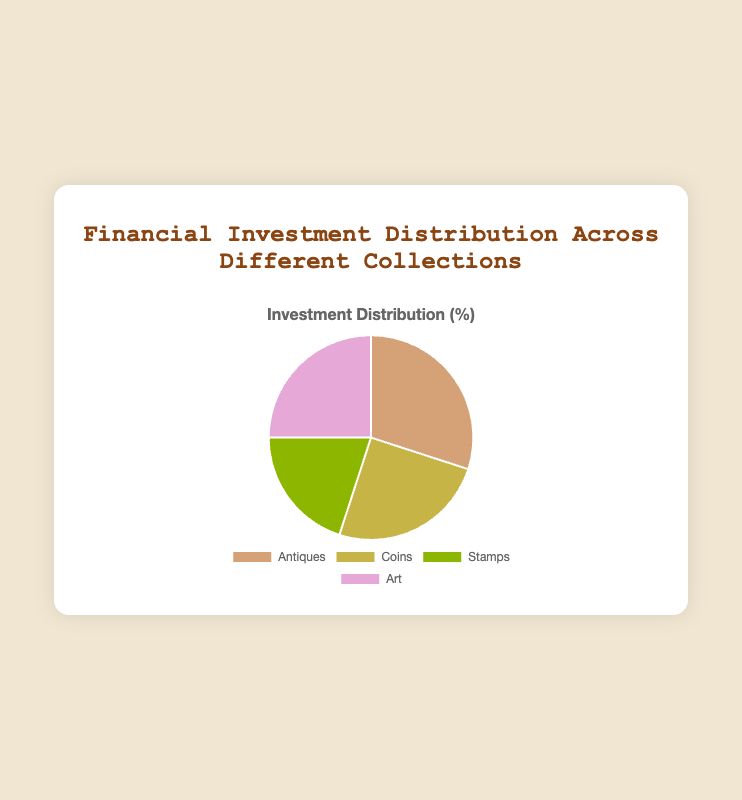What is the total percentage of investment allocated to Coins and Art? To find the total percentage of investment for Coins and Art, you need to sum their individual percentages: 25% (Coins) + 25% (Art) = 50%.
Answer: 50% Which collection has the highest investment percentage? To determine the collection with the highest investment, compare the percentages given: Antiques (30%), Coins (25%), Stamps (20%), and Art (25%). Antiques have the highest percentage at 30%.
Answer: Antiques How many collections have an investment percentage greater than 20%? Identify the collections with investment percentages above 20%. Antiques (30%), Coins (25%), and Art (25%) all exceed 20%. There are 3 collections.
Answer: 3 What is the combined investment percentage for collections with less than 25% investment? Identify the collections with less than 25% investment: Stamps (20%). The percentage is already given as 20%.
Answer: 20% What is the difference in investment percentage between Antiques and Stamps? Subtract the investment percentage of Stamps from that of Antiques: 30% (Antiques) - 20% (Stamps) = 10%.
Answer: 10% Which collection has the lowest investment percentage, and what is it? Compare the percentages provided: Antiques (30%), Coins (25%), Stamps (20%), and Art (25%). Stamps have the lowest investment percentage at 20%.
Answer: Stamps, 20% Is the investment percentage for Antiques more than double compared to Stamps? Double the investment percentage of Stamps (20%) is 40%. The investment percentage for Antiques is 30%, which is less than 40%.
Answer: No What is the average investment percentage across all collections? Sum all the investment percentages and divide by the number of collections: (30% + 25% + 20% + 25%) / 4 = 100% / 4 = 25%.
Answer: 25% Are there any collections with equal investment percentages? Compare the investment percentages: Coins (25%) and Art (25%) have the same investment percentage.
Answer: Yes, Coins and Art 